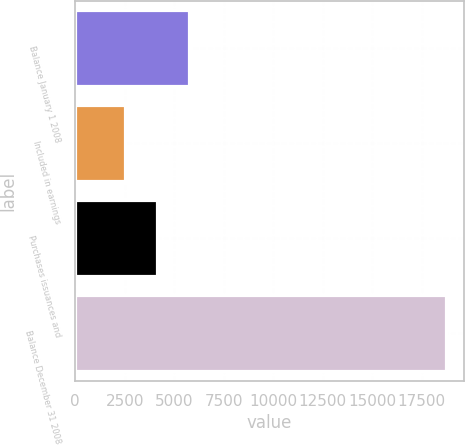Convert chart to OTSL. <chart><loc_0><loc_0><loc_500><loc_500><bar_chart><fcel>Balance January 1 2008<fcel>Included in earnings<fcel>Purchases issuances and<fcel>Balance December 31 2008<nl><fcel>5747.6<fcel>2509<fcel>4128.3<fcel>18702<nl></chart> 